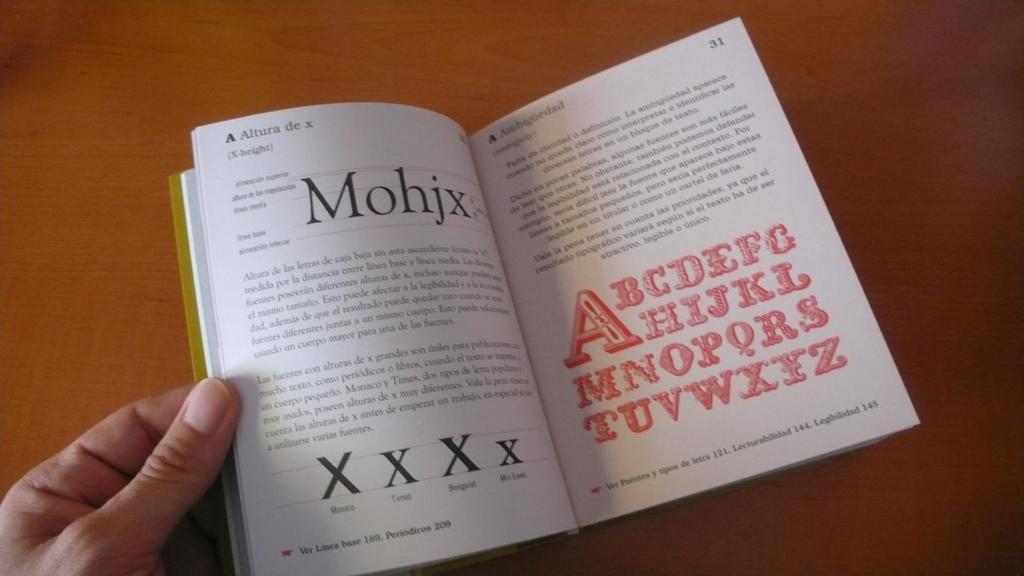What page is the alphabet listed on?
Ensure brevity in your answer.  31. 